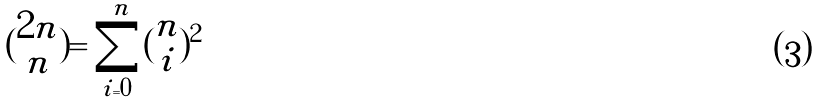<formula> <loc_0><loc_0><loc_500><loc_500>( \begin{matrix} 2 n \\ n \end{matrix} ) = \sum _ { i = 0 } ^ { n } ( \begin{matrix} n \\ i \end{matrix} ) ^ { 2 }</formula> 